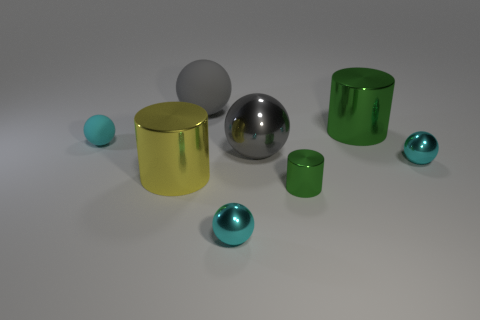How many cyan spheres must be subtracted to get 1 cyan spheres? 2 Subtract all big gray balls. How many balls are left? 3 Subtract all gray cylinders. How many cyan spheres are left? 3 Subtract all gray spheres. How many spheres are left? 3 Add 2 gray balls. How many objects exist? 10 Subtract 2 balls. How many balls are left? 3 Subtract all spheres. How many objects are left? 3 Subtract all cyan cylinders. Subtract all gray spheres. How many cylinders are left? 3 Subtract 0 gray cubes. How many objects are left? 8 Subtract all cyan rubber spheres. Subtract all tiny matte spheres. How many objects are left? 6 